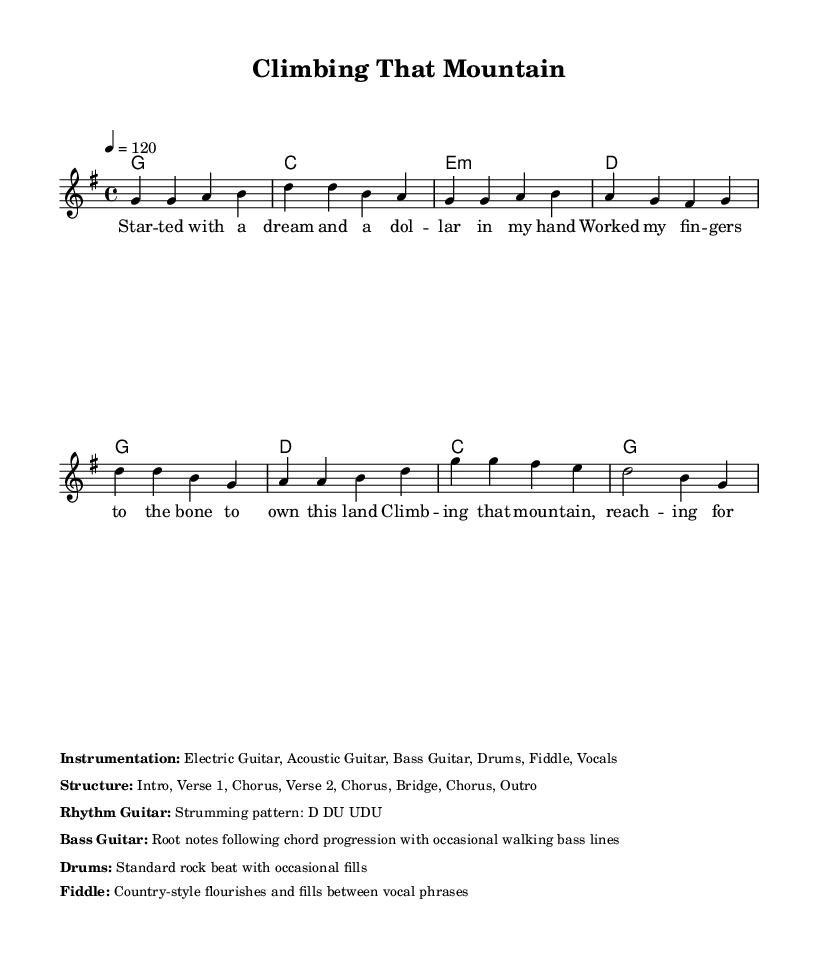What is the key signature of this music? The key signature in the music is G major, which has one sharp (F#). This is indicated at the beginning of the score where the key signature is shown.
Answer: G major What is the time signature of the piece? The time signature is 4/4, which indicates there are four beats in each measure and the quarter note gets one beat. This is indicated at the beginning of the score right after the key signature.
Answer: 4/4 What is the tempo marking of the piece? The tempo marking is given as 120 beats per minute, which is indicated by the tempo expression right after the time signature. This indicates how fast the piece should be played.
Answer: 120 What are the primary instruments used in this piece? The instrumentation is listed in the markup section of the score, noting that the instruments are Electric Guitar, Acoustic Guitar, Bass Guitar, Drums, Fiddle, and Vocals. This provides a clear picture of the band set-up for performance.
Answer: Electric Guitar, Acoustic Guitar, Bass Guitar, Drums, Fiddle, Vocals What is the structure of the song? The structure is detailed in the markup section and consists of an Intro, Verse 1, Chorus, Verse 2, Chorus, Bridge, Chorus, and Outro. Each of these sections plays a role in the overall composition and flow of the song.
Answer: Intro, Verse 1, Chorus, Verse 2, Chorus, Bridge, Chorus, Outro How is the rhythm guitar played in this song? The strumming pattern for the rhythm guitar is listed in the markup as D DU UDU, indicating a varied strumming pattern that contributes to the song's rhythmic feel. This information helps performers know how to play the rhythm part effectively.
Answer: D DU UDU 